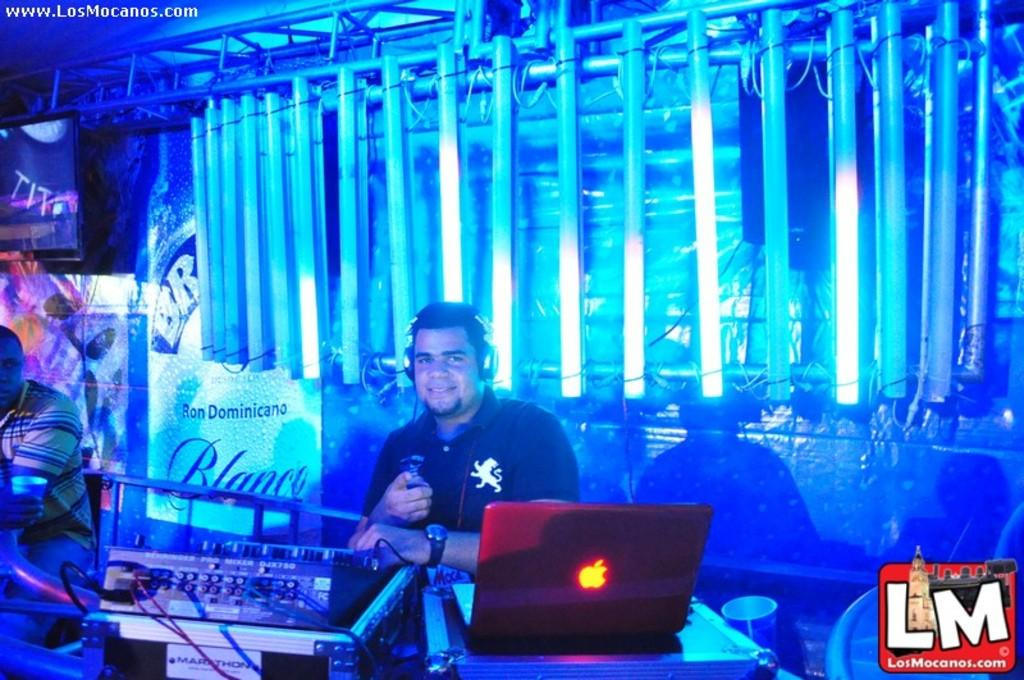<image>
Create a compact narrative representing the image presented. A DJ sitting behind his equipment and a sign that reads Ron Dominicano. 